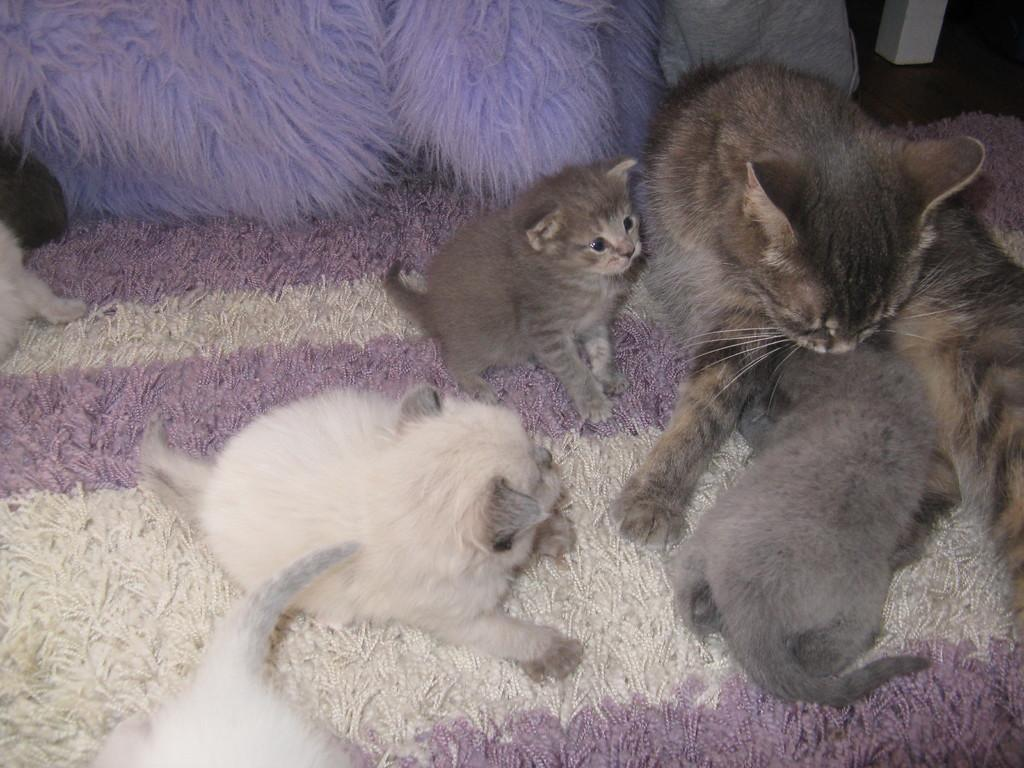What animal is present in the image? There is a cat in the image. Where is the cat located? The cat is sitting on a carpet. Are there any other animals in the image? Yes, there are small kittens in the image. What type of string is the cat playing with in the image? There is no string present in the image; the cat is sitting on a carpet. 